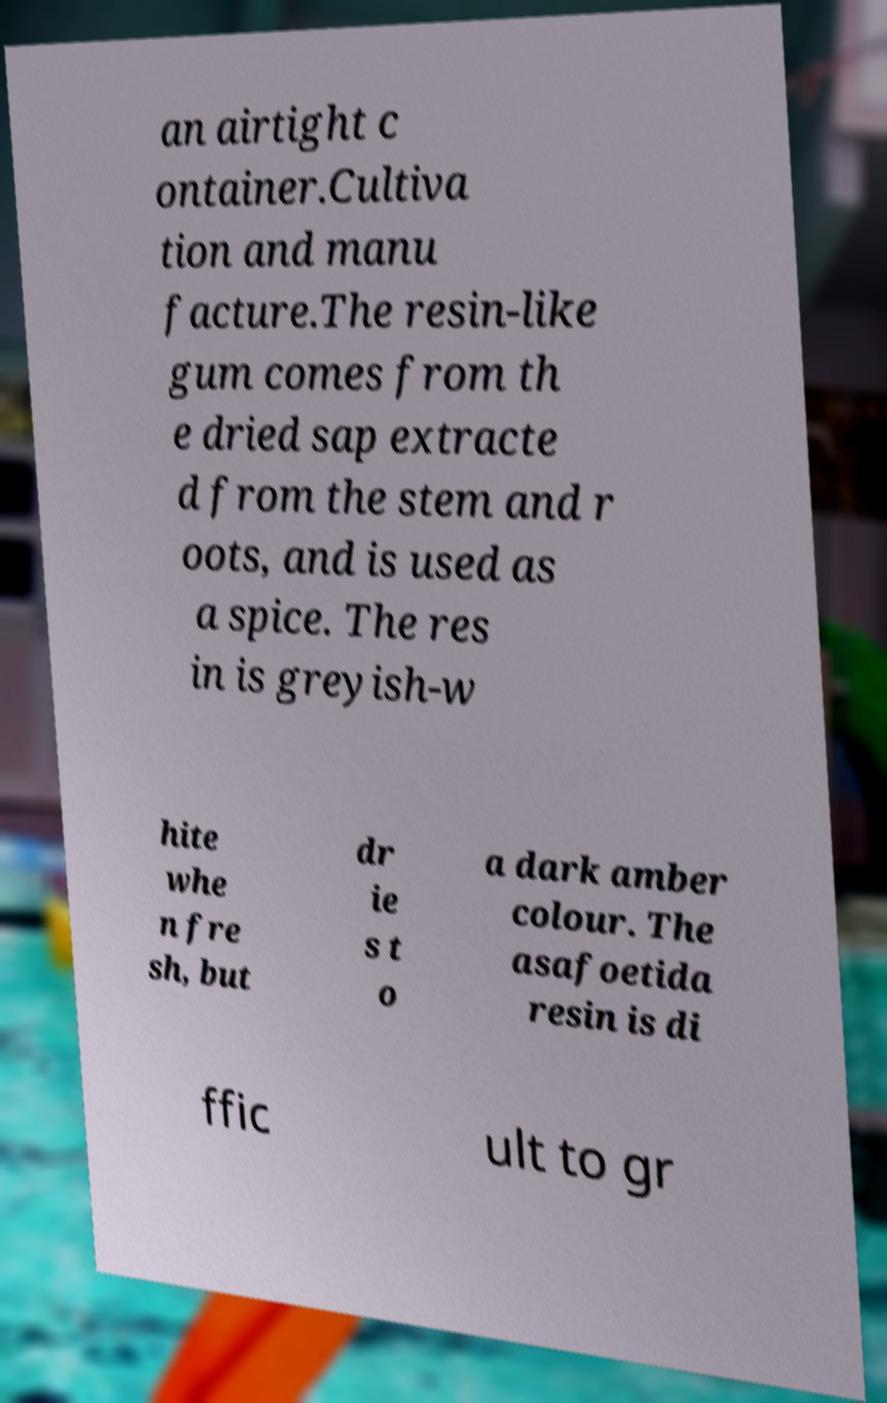Could you extract and type out the text from this image? an airtight c ontainer.Cultiva tion and manu facture.The resin-like gum comes from th e dried sap extracte d from the stem and r oots, and is used as a spice. The res in is greyish-w hite whe n fre sh, but dr ie s t o a dark amber colour. The asafoetida resin is di ffic ult to gr 